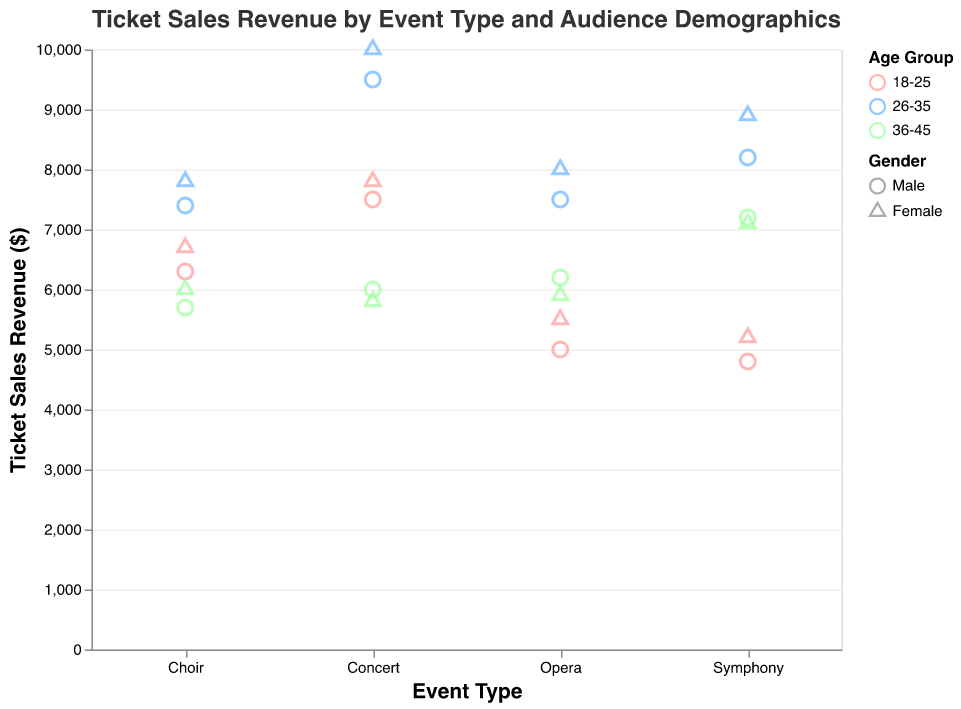How many different event types are displayed in the figure? The x-axis shows distinct event types. Identify and count them.
Answer: 4 Which event and age group combination has the highest ticket sales revenue? Look at the y-axis values and find the highest one, then trace its corresponding Event and Age Group indicated by color.
Answer: Spring Concert, 26-35, Female What is the total ticket sales revenue for the audience aged 18-25 for all events? Sum the ticket sales revenue for the 18-25 age group across all events.
Answer: $34,700 How does the ticket sales revenue for males and females aged 26-35 compare for the Summer Opera? Compare the y-axis values for the 26-35 age group's males and females under the Summer Opera event type.
Answer: Females have slightly higher revenue than males What is the difference in ticket sales revenue between males and females aged 36-45 for the Winter Choir Performance? Subtract the male revenue from the female revenue for the 36-45 age group in Winter Choir Performance.
Answer: $300 Which event type has the smallest difference in ticket sales revenue between the youngest (18-25) and oldest (36-45) age groups? Calculate the difference in revenue between 18-25 and 36-45 for each event type and find the smallest one.
Answer: Autumn Symphony Are there more data points for male or female audiences in the figure? Count the total number of data points for each gender and compare.
Answer: Female For the Spring Concert, how does the ticket sales revenue of the 26-35 age group compare to the 18-25 age group? Subtract the total revenue of the 18-25 group from the 26-35 group for the Spring Concert.
Answer: $4,200 more What is the average ticket sales revenue for audience aged 36-45 across all events? Sum the ticket sales revenue for the 36-45 age group across all events, then divide by the number of events.
Answer: $6,400 